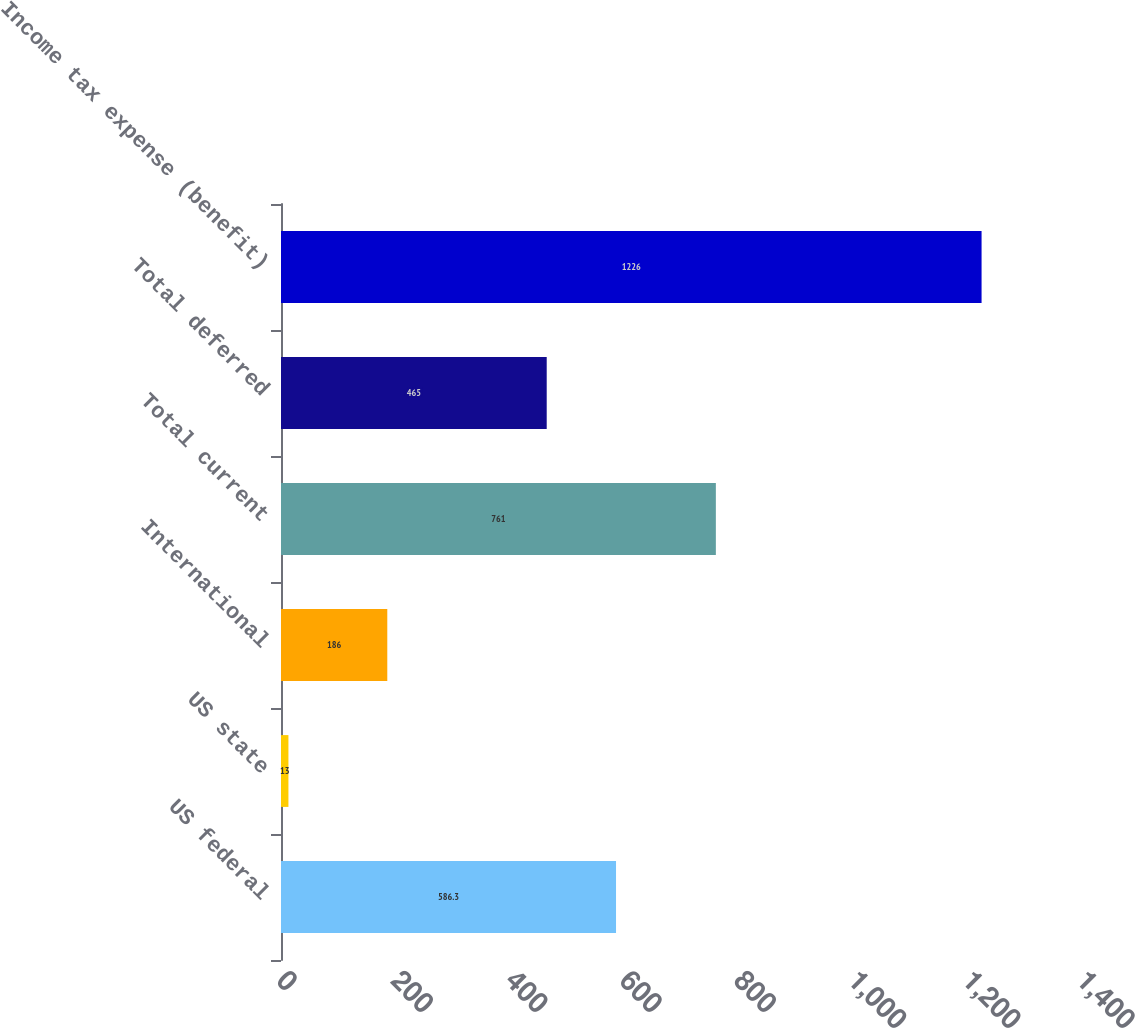Convert chart. <chart><loc_0><loc_0><loc_500><loc_500><bar_chart><fcel>US federal<fcel>US state<fcel>International<fcel>Total current<fcel>Total deferred<fcel>Income tax expense (benefit)<nl><fcel>586.3<fcel>13<fcel>186<fcel>761<fcel>465<fcel>1226<nl></chart> 